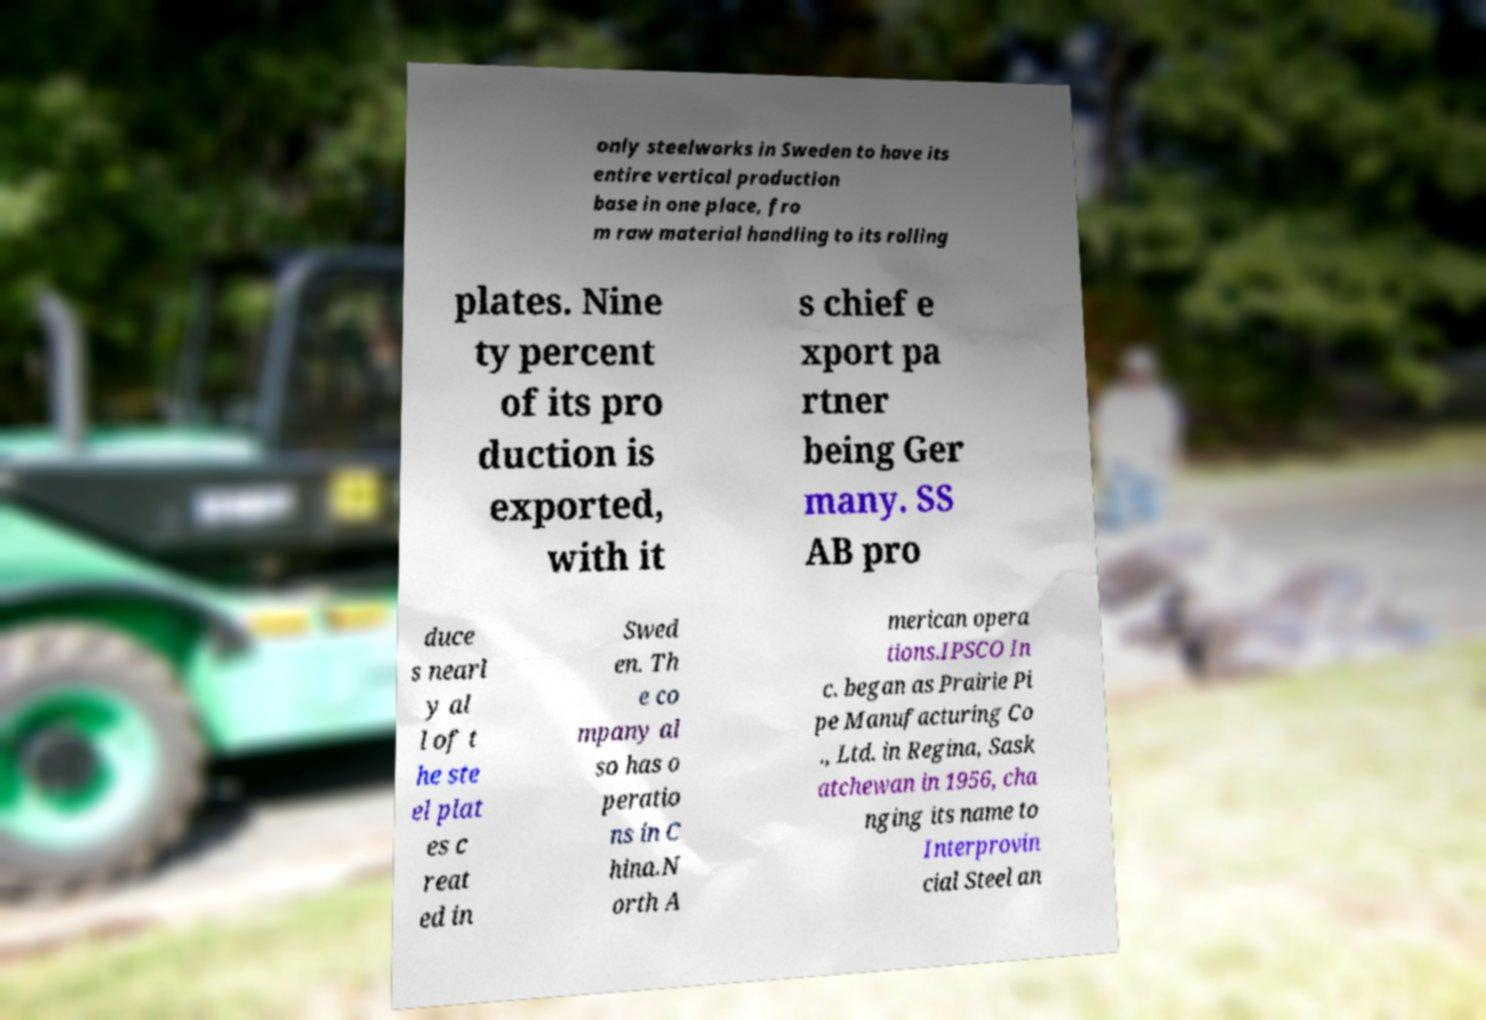Please read and relay the text visible in this image. What does it say? only steelworks in Sweden to have its entire vertical production base in one place, fro m raw material handling to its rolling plates. Nine ty percent of its pro duction is exported, with it s chief e xport pa rtner being Ger many. SS AB pro duce s nearl y al l of t he ste el plat es c reat ed in Swed en. Th e co mpany al so has o peratio ns in C hina.N orth A merican opera tions.IPSCO In c. began as Prairie Pi pe Manufacturing Co ., Ltd. in Regina, Sask atchewan in 1956, cha nging its name to Interprovin cial Steel an 